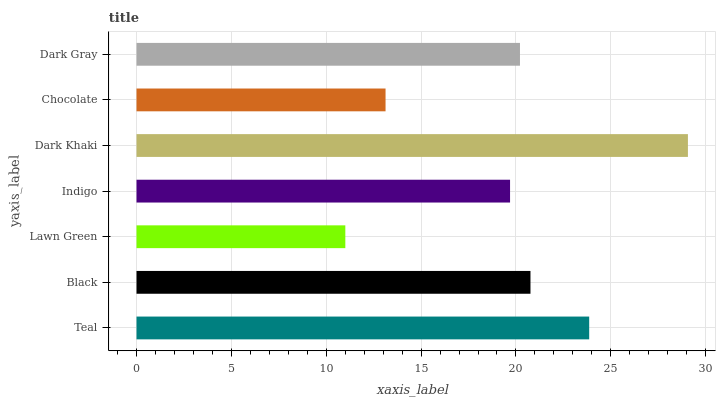Is Lawn Green the minimum?
Answer yes or no. Yes. Is Dark Khaki the maximum?
Answer yes or no. Yes. Is Black the minimum?
Answer yes or no. No. Is Black the maximum?
Answer yes or no. No. Is Teal greater than Black?
Answer yes or no. Yes. Is Black less than Teal?
Answer yes or no. Yes. Is Black greater than Teal?
Answer yes or no. No. Is Teal less than Black?
Answer yes or no. No. Is Dark Gray the high median?
Answer yes or no. Yes. Is Dark Gray the low median?
Answer yes or no. Yes. Is Dark Khaki the high median?
Answer yes or no. No. Is Teal the low median?
Answer yes or no. No. 